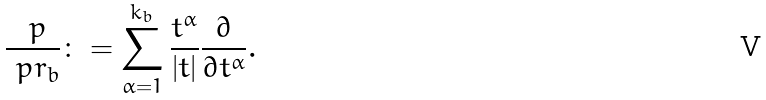Convert formula to latex. <formula><loc_0><loc_0><loc_500><loc_500>\frac { \ p } { \ p r _ { b } } \colon = \sum _ { \alpha = 1 } ^ { k _ { b } } \frac { t ^ { \alpha } } { | t | } \frac { \partial } { \partial t ^ { \alpha } } .</formula> 